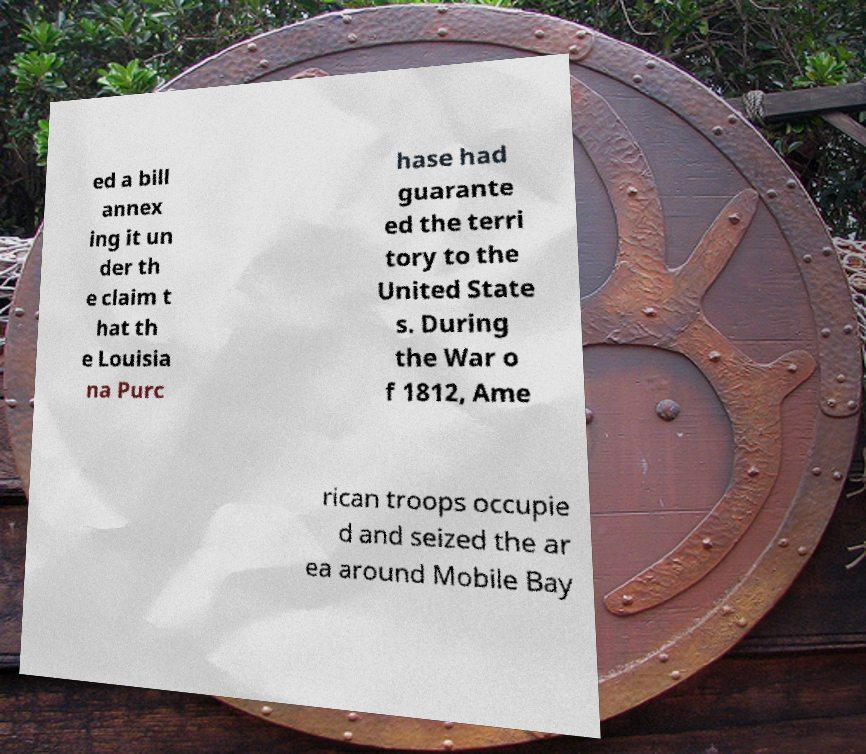Can you accurately transcribe the text from the provided image for me? ed a bill annex ing it un der th e claim t hat th e Louisia na Purc hase had guarante ed the terri tory to the United State s. During the War o f 1812, Ame rican troops occupie d and seized the ar ea around Mobile Bay 